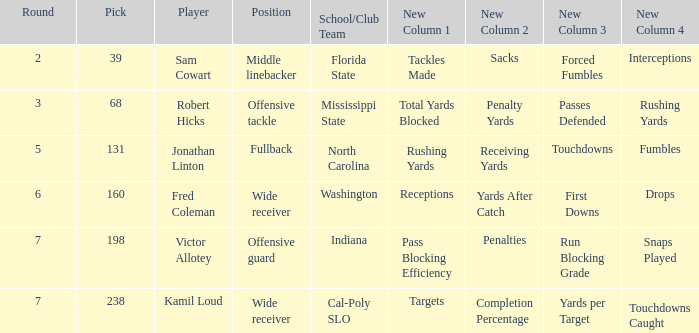Which School/Club Team has a Pick of 198? Indiana. Can you give me this table as a dict? {'header': ['Round', 'Pick', 'Player', 'Position', 'School/Club Team', 'New Column 1', 'New Column 2', 'New Column 3', 'New Column 4'], 'rows': [['2', '39', 'Sam Cowart', 'Middle linebacker', 'Florida State', 'Tackles Made', 'Sacks', 'Forced Fumbles', 'Interceptions'], ['3', '68', 'Robert Hicks', 'Offensive tackle', 'Mississippi State', 'Total Yards Blocked', 'Penalty Yards', 'Passes Defended', 'Rushing Yards'], ['5', '131', 'Jonathan Linton', 'Fullback', 'North Carolina', 'Rushing Yards', 'Receiving Yards', 'Touchdowns', 'Fumbles'], ['6', '160', 'Fred Coleman', 'Wide receiver', 'Washington', 'Receptions', 'Yards After Catch', 'First Downs', 'Drops'], ['7', '198', 'Victor Allotey', 'Offensive guard', 'Indiana', 'Pass Blocking Efficiency', 'Penalties', 'Run Blocking Grade', 'Snaps Played'], ['7', '238', 'Kamil Loud', 'Wide receiver', 'Cal-Poly SLO', 'Targets', 'Completion Percentage', 'Yards per Target', 'Touchdowns Caught']]} 